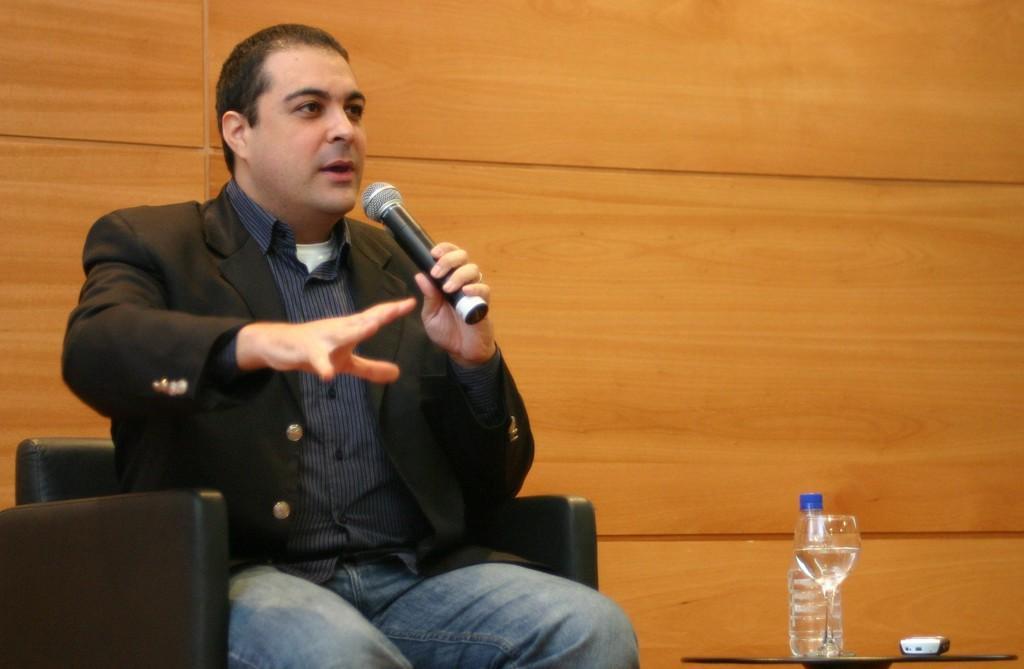Please provide a concise description of this image. In this picture we can see a man is seated on the chair, he is holding a microphone, in front of him we can find a bottle, glass and a mobile on the table. 